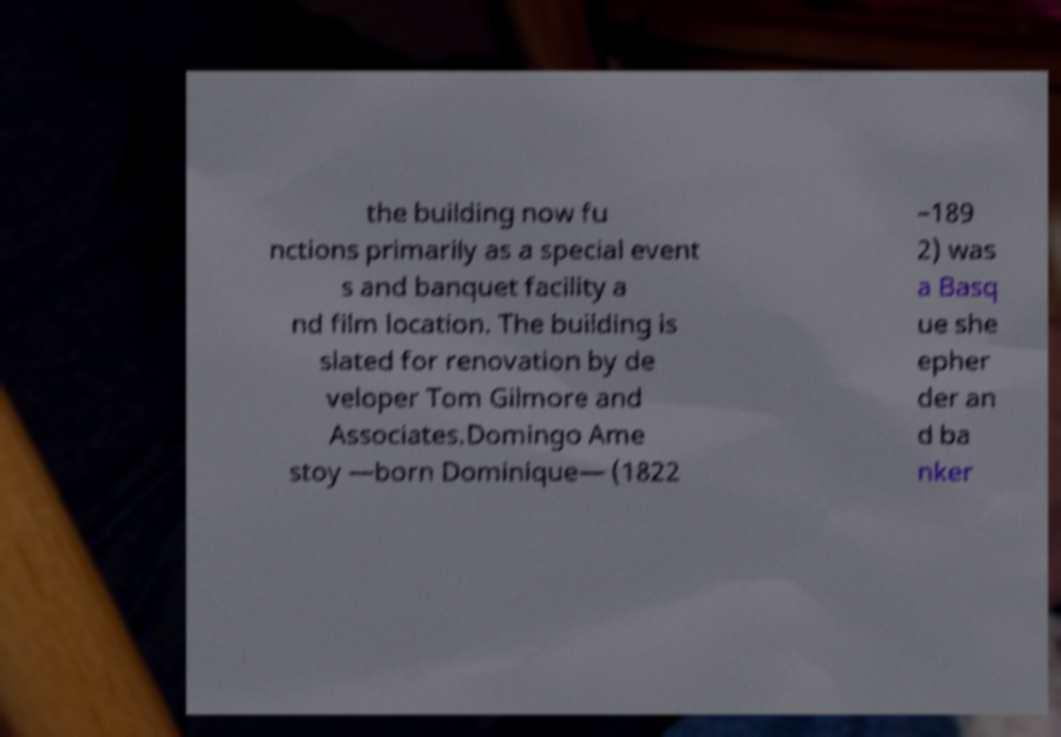There's text embedded in this image that I need extracted. Can you transcribe it verbatim? the building now fu nctions primarily as a special event s and banquet facility a nd film location. The building is slated for renovation by de veloper Tom Gilmore and Associates.Domingo Ame stoy —born Dominique— (1822 –189 2) was a Basq ue she epher der an d ba nker 